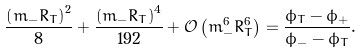Convert formula to latex. <formula><loc_0><loc_0><loc_500><loc_500>\frac { { \left ( { m _ { - } R _ { T } } \right ) ^ { 2 } } } { 8 } + \frac { { \left ( { m _ { - } R _ { T } } \right ) ^ { 4 } } } { 1 9 2 } + \mathcal { O } \left ( { m _ { - } ^ { 6 } R _ { T } ^ { 6 } } \right ) = \frac { \phi _ { T } - \phi _ { + } } { \phi _ { - } - \phi _ { T } } .</formula> 